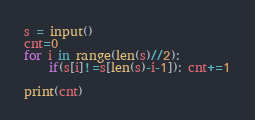Convert code to text. <code><loc_0><loc_0><loc_500><loc_500><_Python_>s = input()
cnt=0
for i in range(len(s)//2):
    if(s[i]!=s[len(s)-i-1]): cnt+=1

print(cnt)</code> 